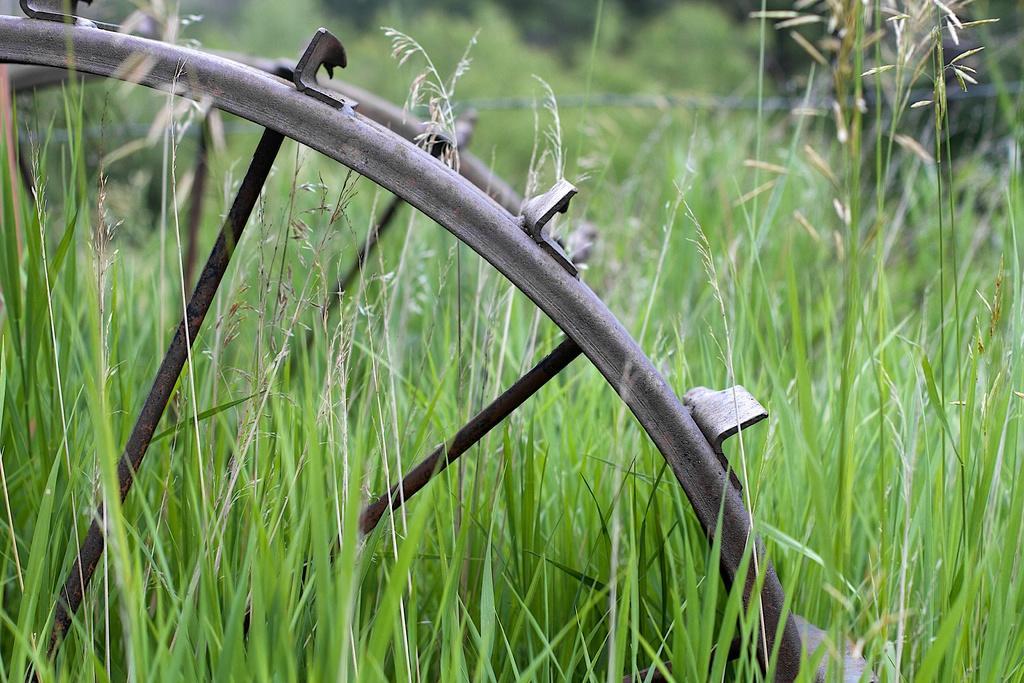Describe this image in one or two sentences. In this image I can see a metal object which is grey and black in color and few plants which are green and cream in color. I can see the blurry background. 